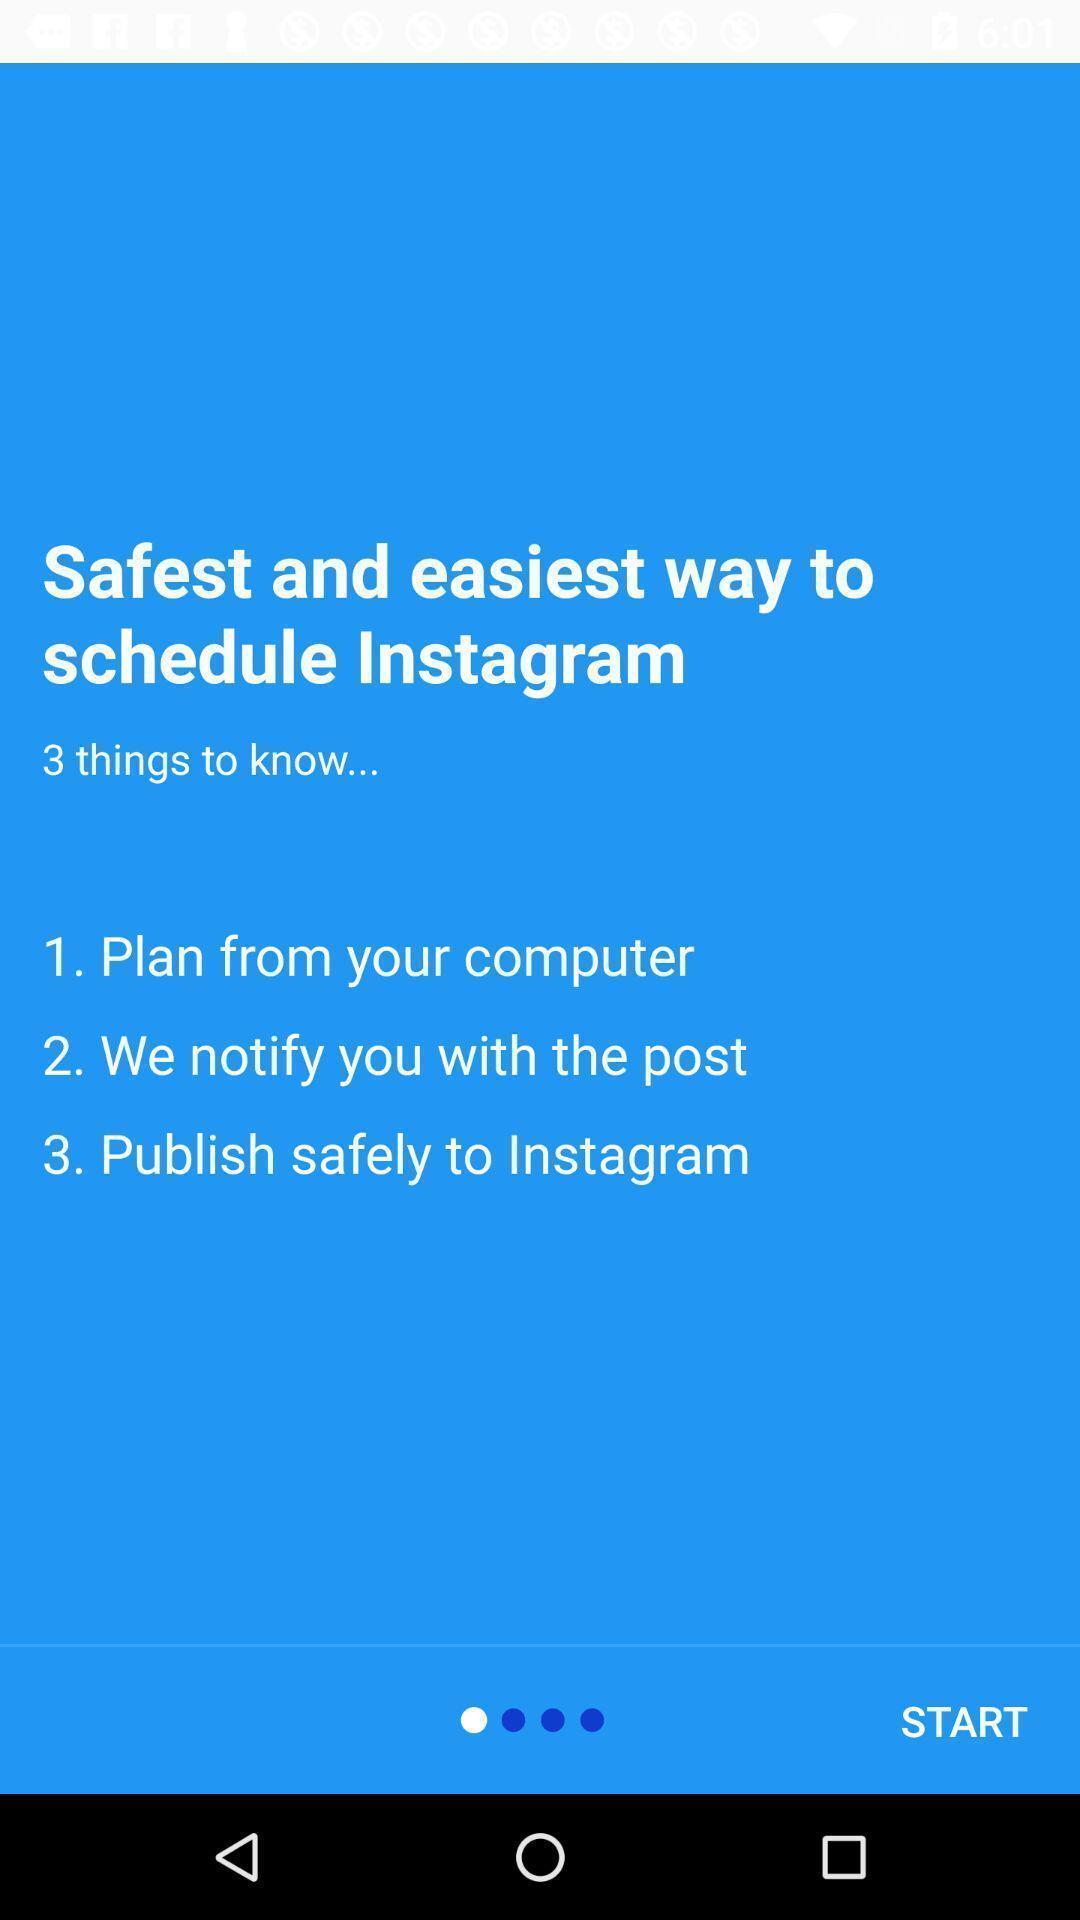Describe this image in words. Starting page with instructions for a social app. 